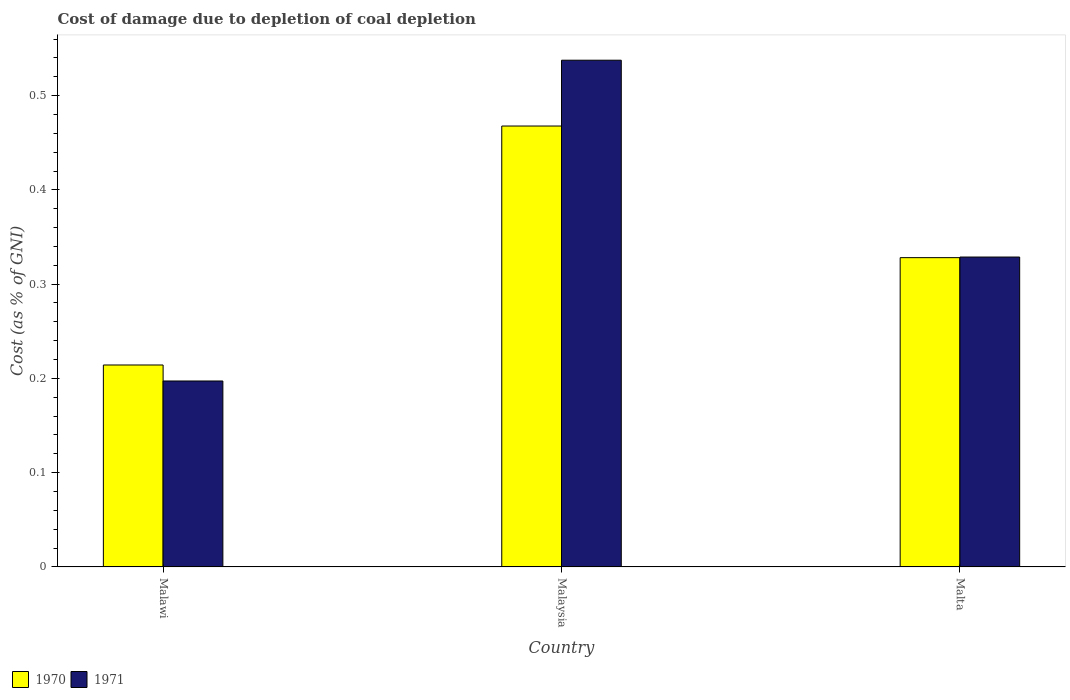How many different coloured bars are there?
Offer a very short reply. 2. Are the number of bars per tick equal to the number of legend labels?
Give a very brief answer. Yes. Are the number of bars on each tick of the X-axis equal?
Offer a terse response. Yes. How many bars are there on the 3rd tick from the right?
Your response must be concise. 2. What is the label of the 2nd group of bars from the left?
Offer a terse response. Malaysia. In how many cases, is the number of bars for a given country not equal to the number of legend labels?
Provide a short and direct response. 0. What is the cost of damage caused due to coal depletion in 1971 in Malaysia?
Your response must be concise. 0.54. Across all countries, what is the maximum cost of damage caused due to coal depletion in 1970?
Your answer should be very brief. 0.47. Across all countries, what is the minimum cost of damage caused due to coal depletion in 1971?
Your response must be concise. 0.2. In which country was the cost of damage caused due to coal depletion in 1971 maximum?
Give a very brief answer. Malaysia. In which country was the cost of damage caused due to coal depletion in 1971 minimum?
Make the answer very short. Malawi. What is the total cost of damage caused due to coal depletion in 1970 in the graph?
Your response must be concise. 1.01. What is the difference between the cost of damage caused due to coal depletion in 1970 in Malaysia and that in Malta?
Offer a terse response. 0.14. What is the difference between the cost of damage caused due to coal depletion in 1970 in Malawi and the cost of damage caused due to coal depletion in 1971 in Malaysia?
Offer a very short reply. -0.32. What is the average cost of damage caused due to coal depletion in 1970 per country?
Provide a succinct answer. 0.34. What is the difference between the cost of damage caused due to coal depletion of/in 1970 and cost of damage caused due to coal depletion of/in 1971 in Malawi?
Your response must be concise. 0.02. What is the ratio of the cost of damage caused due to coal depletion in 1970 in Malaysia to that in Malta?
Your answer should be compact. 1.43. Is the difference between the cost of damage caused due to coal depletion in 1970 in Malaysia and Malta greater than the difference between the cost of damage caused due to coal depletion in 1971 in Malaysia and Malta?
Your response must be concise. No. What is the difference between the highest and the second highest cost of damage caused due to coal depletion in 1970?
Give a very brief answer. 0.14. What is the difference between the highest and the lowest cost of damage caused due to coal depletion in 1970?
Give a very brief answer. 0.25. In how many countries, is the cost of damage caused due to coal depletion in 1970 greater than the average cost of damage caused due to coal depletion in 1970 taken over all countries?
Provide a succinct answer. 1. Is the sum of the cost of damage caused due to coal depletion in 1971 in Malawi and Malta greater than the maximum cost of damage caused due to coal depletion in 1970 across all countries?
Give a very brief answer. Yes. What is the difference between two consecutive major ticks on the Y-axis?
Your answer should be compact. 0.1. Does the graph contain any zero values?
Your answer should be very brief. No. Where does the legend appear in the graph?
Your answer should be very brief. Bottom left. How are the legend labels stacked?
Offer a very short reply. Horizontal. What is the title of the graph?
Your answer should be compact. Cost of damage due to depletion of coal depletion. Does "1996" appear as one of the legend labels in the graph?
Keep it short and to the point. No. What is the label or title of the X-axis?
Provide a succinct answer. Country. What is the label or title of the Y-axis?
Provide a succinct answer. Cost (as % of GNI). What is the Cost (as % of GNI) of 1970 in Malawi?
Provide a short and direct response. 0.21. What is the Cost (as % of GNI) of 1971 in Malawi?
Offer a terse response. 0.2. What is the Cost (as % of GNI) of 1970 in Malaysia?
Offer a terse response. 0.47. What is the Cost (as % of GNI) in 1971 in Malaysia?
Provide a short and direct response. 0.54. What is the Cost (as % of GNI) in 1970 in Malta?
Provide a short and direct response. 0.33. What is the Cost (as % of GNI) of 1971 in Malta?
Your response must be concise. 0.33. Across all countries, what is the maximum Cost (as % of GNI) of 1970?
Provide a short and direct response. 0.47. Across all countries, what is the maximum Cost (as % of GNI) of 1971?
Your answer should be compact. 0.54. Across all countries, what is the minimum Cost (as % of GNI) in 1970?
Ensure brevity in your answer.  0.21. Across all countries, what is the minimum Cost (as % of GNI) of 1971?
Offer a very short reply. 0.2. What is the total Cost (as % of GNI) of 1971 in the graph?
Offer a very short reply. 1.06. What is the difference between the Cost (as % of GNI) of 1970 in Malawi and that in Malaysia?
Your answer should be compact. -0.25. What is the difference between the Cost (as % of GNI) of 1971 in Malawi and that in Malaysia?
Provide a succinct answer. -0.34. What is the difference between the Cost (as % of GNI) of 1970 in Malawi and that in Malta?
Your answer should be compact. -0.11. What is the difference between the Cost (as % of GNI) of 1971 in Malawi and that in Malta?
Provide a succinct answer. -0.13. What is the difference between the Cost (as % of GNI) in 1970 in Malaysia and that in Malta?
Offer a terse response. 0.14. What is the difference between the Cost (as % of GNI) in 1971 in Malaysia and that in Malta?
Your answer should be compact. 0.21. What is the difference between the Cost (as % of GNI) in 1970 in Malawi and the Cost (as % of GNI) in 1971 in Malaysia?
Provide a succinct answer. -0.32. What is the difference between the Cost (as % of GNI) of 1970 in Malawi and the Cost (as % of GNI) of 1971 in Malta?
Offer a very short reply. -0.11. What is the difference between the Cost (as % of GNI) in 1970 in Malaysia and the Cost (as % of GNI) in 1971 in Malta?
Your answer should be compact. 0.14. What is the average Cost (as % of GNI) in 1970 per country?
Offer a very short reply. 0.34. What is the average Cost (as % of GNI) in 1971 per country?
Your answer should be very brief. 0.35. What is the difference between the Cost (as % of GNI) in 1970 and Cost (as % of GNI) in 1971 in Malawi?
Offer a very short reply. 0.02. What is the difference between the Cost (as % of GNI) of 1970 and Cost (as % of GNI) of 1971 in Malaysia?
Your answer should be compact. -0.07. What is the difference between the Cost (as % of GNI) of 1970 and Cost (as % of GNI) of 1971 in Malta?
Your response must be concise. -0. What is the ratio of the Cost (as % of GNI) in 1970 in Malawi to that in Malaysia?
Your answer should be very brief. 0.46. What is the ratio of the Cost (as % of GNI) of 1971 in Malawi to that in Malaysia?
Provide a succinct answer. 0.37. What is the ratio of the Cost (as % of GNI) in 1970 in Malawi to that in Malta?
Your answer should be very brief. 0.65. What is the ratio of the Cost (as % of GNI) in 1970 in Malaysia to that in Malta?
Make the answer very short. 1.43. What is the ratio of the Cost (as % of GNI) of 1971 in Malaysia to that in Malta?
Your response must be concise. 1.64. What is the difference between the highest and the second highest Cost (as % of GNI) of 1970?
Keep it short and to the point. 0.14. What is the difference between the highest and the second highest Cost (as % of GNI) of 1971?
Provide a short and direct response. 0.21. What is the difference between the highest and the lowest Cost (as % of GNI) of 1970?
Offer a very short reply. 0.25. What is the difference between the highest and the lowest Cost (as % of GNI) in 1971?
Ensure brevity in your answer.  0.34. 